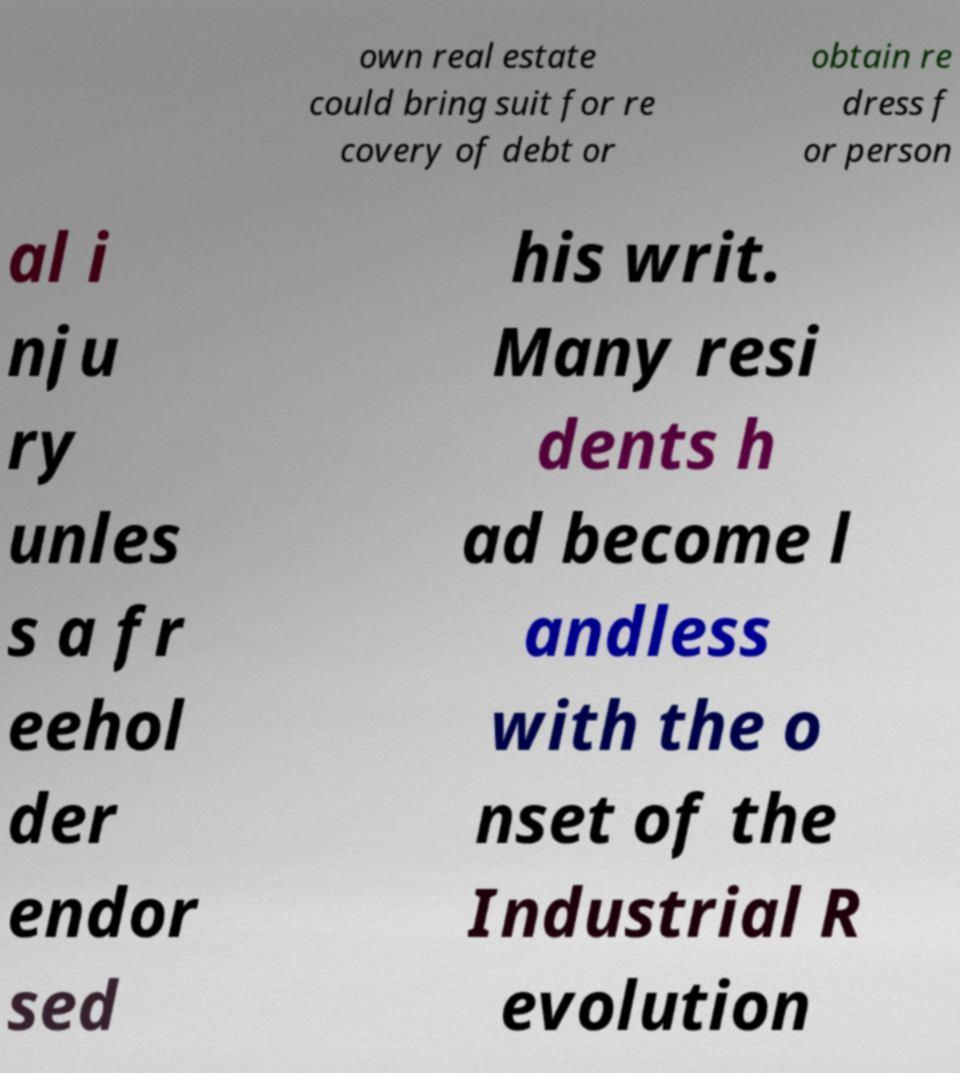I need the written content from this picture converted into text. Can you do that? own real estate could bring suit for re covery of debt or obtain re dress f or person al i nju ry unles s a fr eehol der endor sed his writ. Many resi dents h ad become l andless with the o nset of the Industrial R evolution 